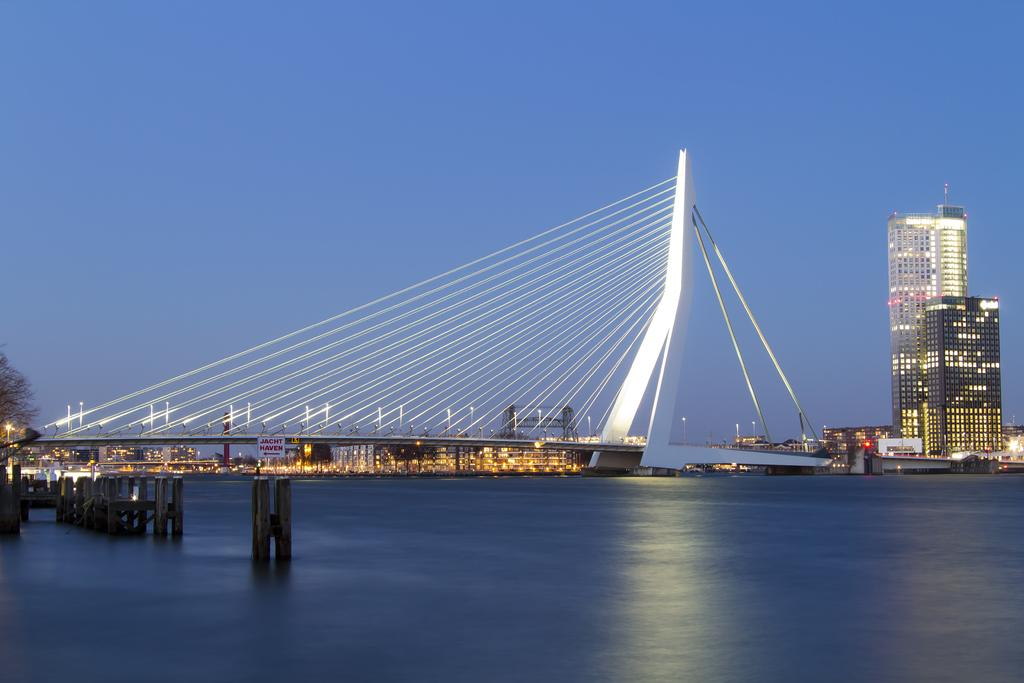What structure can be seen in the image? There is a bridge in the image. What is visible at the bottom of the image? There is water visible at the bottom of the image. What type of buildings can be seen on the right side of the image? Skyscrapers are present on the right side of the image. What is visible at the top of the image? The sky is visible at the top of the image. Where is the hose located in the image? There is no hose present in the image. What type of lock is securing the bridge in the image? There is no lock securing the bridge in the image; it is not mentioned in the provided facts. 